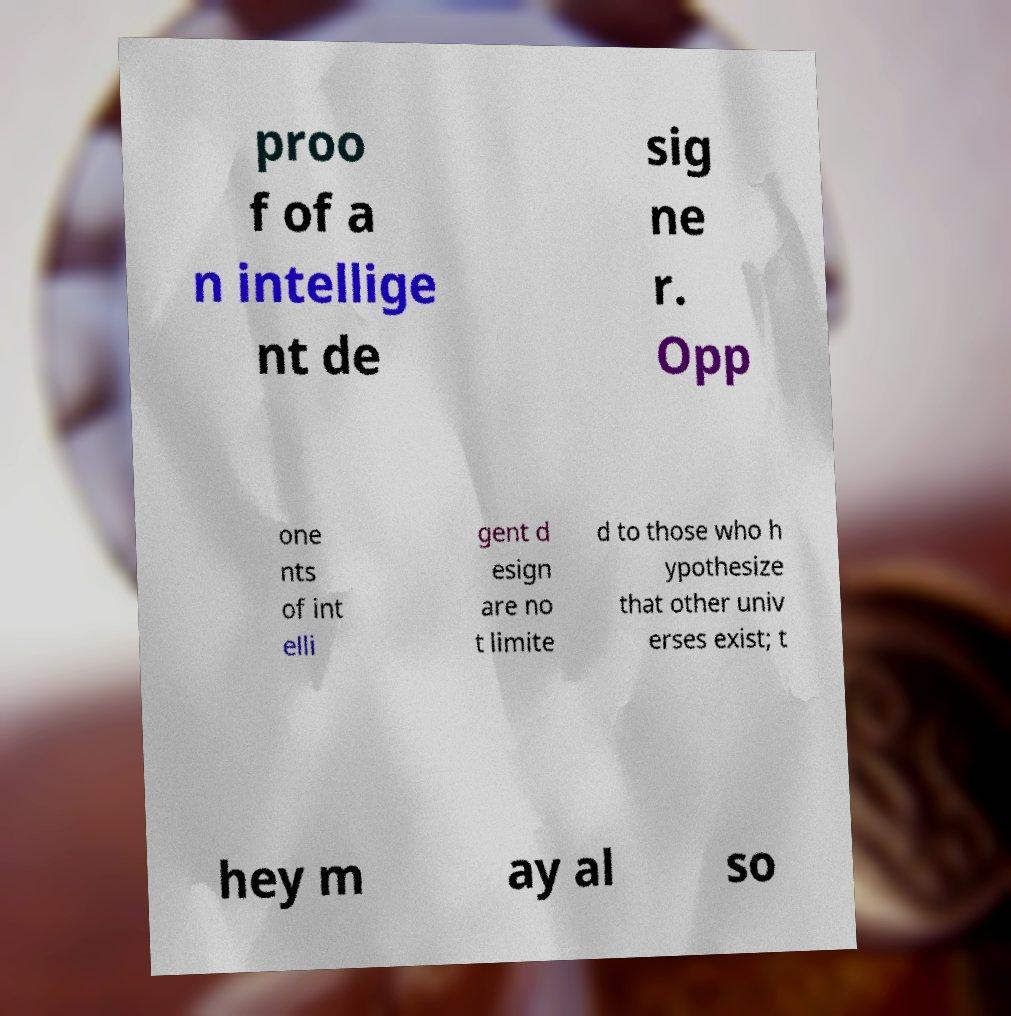Could you assist in decoding the text presented in this image and type it out clearly? proo f of a n intellige nt de sig ne r. Opp one nts of int elli gent d esign are no t limite d to those who h ypothesize that other univ erses exist; t hey m ay al so 